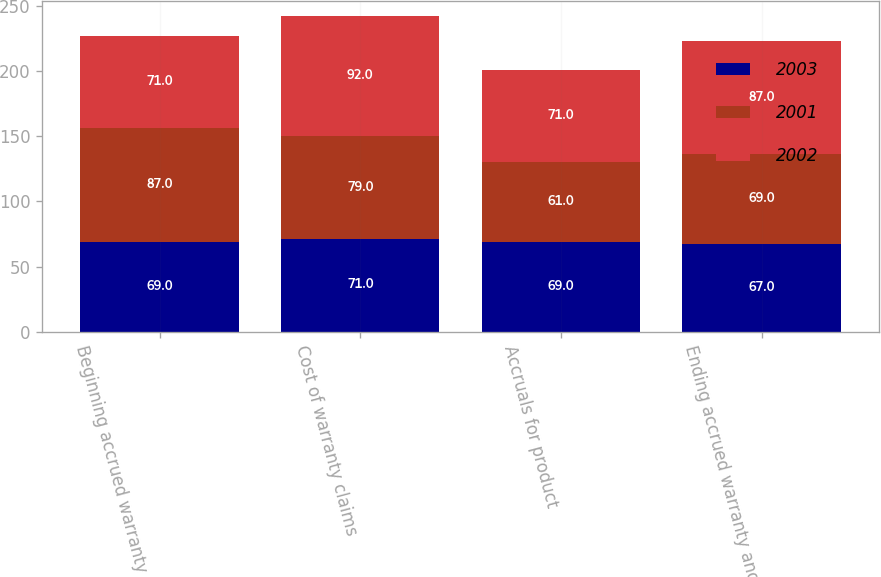<chart> <loc_0><loc_0><loc_500><loc_500><stacked_bar_chart><ecel><fcel>Beginning accrued warranty and<fcel>Cost of warranty claims<fcel>Accruals for product<fcel>Ending accrued warranty and<nl><fcel>2003<fcel>69<fcel>71<fcel>69<fcel>67<nl><fcel>2001<fcel>87<fcel>79<fcel>61<fcel>69<nl><fcel>2002<fcel>71<fcel>92<fcel>71<fcel>87<nl></chart> 